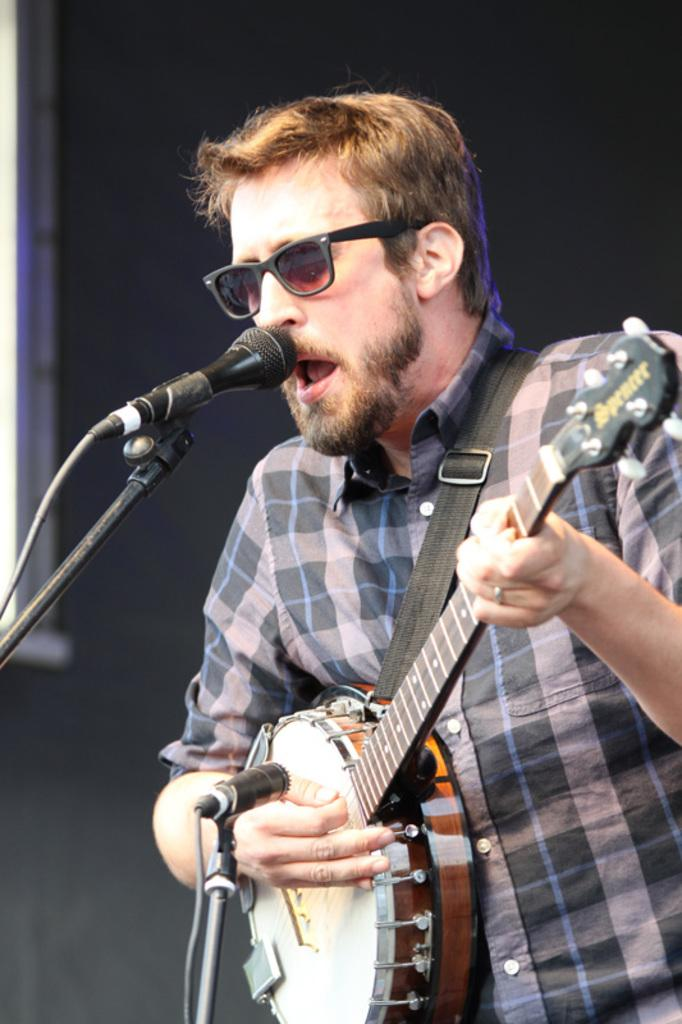What is the man in the image doing? The man is playing a music instrument and singing. What object is the man using to amplify his voice? There is a microphone in the image. What other objects can be seen in the image besides the man and the microphone? There is a rod and wire in the image. What is the color of the background in the image? The background of the image is black. What shape is the sheep in the image? There is no sheep present in the image. What type of tool might the carpenter be using in the image? There is no carpenter or tool present in the image. 